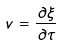Convert formula to latex. <formula><loc_0><loc_0><loc_500><loc_500>v = \frac { \partial \xi } { \partial \tau }</formula> 